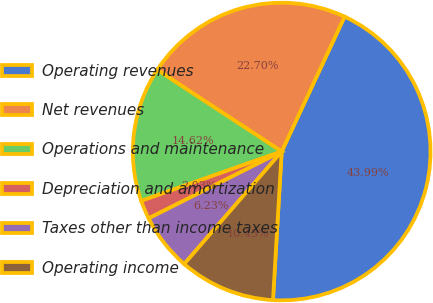Convert chart to OTSL. <chart><loc_0><loc_0><loc_500><loc_500><pie_chart><fcel>Operating revenues<fcel>Net revenues<fcel>Operations and maintenance<fcel>Depreciation and amortization<fcel>Taxes other than income taxes<fcel>Operating income<nl><fcel>43.99%<fcel>22.7%<fcel>14.62%<fcel>2.03%<fcel>6.23%<fcel>10.43%<nl></chart> 